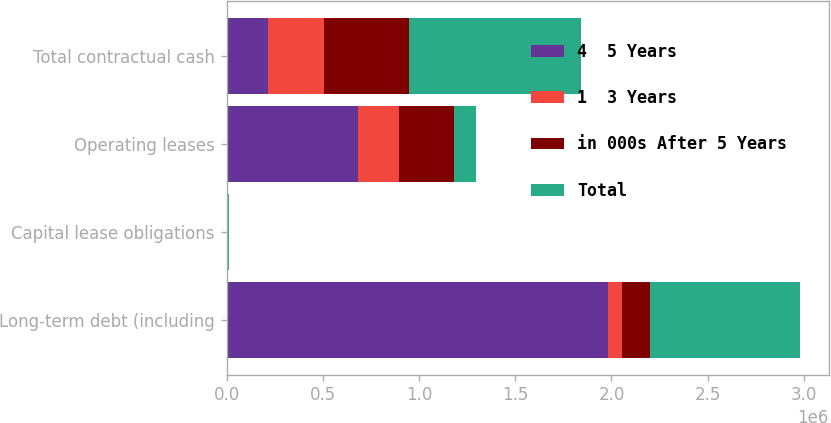Convert chart. <chart><loc_0><loc_0><loc_500><loc_500><stacked_bar_chart><ecel><fcel>Long-term debt (including<fcel>Capital lease obligations<fcel>Operating leases<fcel>Total contractual cash<nl><fcel>4  5 Years<fcel>1.98258e+06<fcel>7435<fcel>680816<fcel>213523<nl><fcel>1  3 Years<fcel>72688<fcel>826<fcel>213523<fcel>294918<nl><fcel>in 000s After 5 Years<fcel>145375<fcel>2007<fcel>290031<fcel>438189<nl><fcel>Total<fcel>780098<fcel>2197<fcel>113381<fcel>895676<nl></chart> 